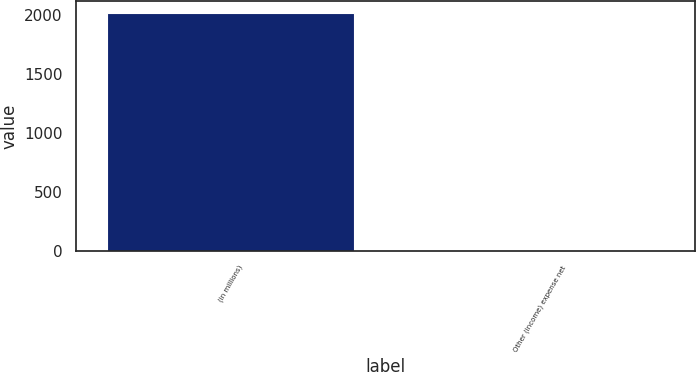Convert chart to OTSL. <chart><loc_0><loc_0><loc_500><loc_500><bar_chart><fcel>(in millions)<fcel>Other (income) expense net<nl><fcel>2016<fcel>8<nl></chart> 